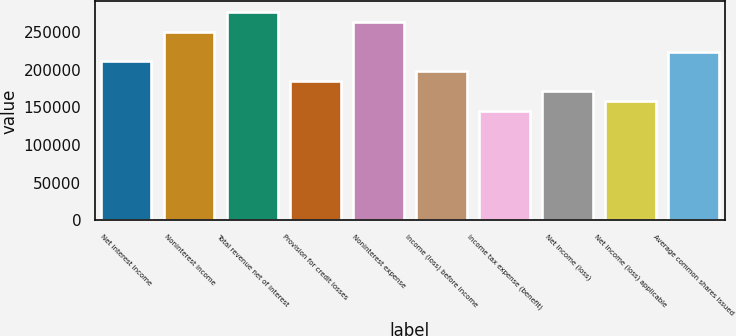Convert chart. <chart><loc_0><loc_0><loc_500><loc_500><bar_chart><fcel>Net interest income<fcel>Noninterest income<fcel>Total revenue net of interest<fcel>Provision for credit losses<fcel>Noninterest expense<fcel>Income (loss) before income<fcel>Income tax expense (benefit)<fcel>Net income (loss)<fcel>Net income (loss) applicable<fcel>Average common shares issued<nl><fcel>210907<fcel>250452<fcel>276816<fcel>184544<fcel>263634<fcel>197726<fcel>144999<fcel>171362<fcel>158180<fcel>224089<nl></chart> 